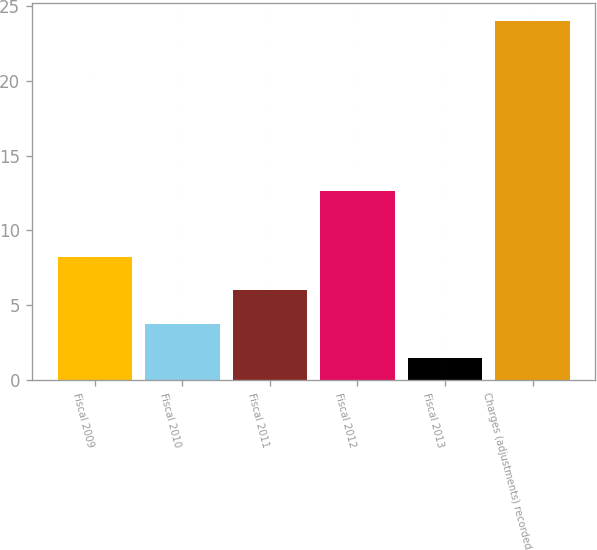Convert chart to OTSL. <chart><loc_0><loc_0><loc_500><loc_500><bar_chart><fcel>Fiscal 2009<fcel>Fiscal 2010<fcel>Fiscal 2011<fcel>Fiscal 2012<fcel>Fiscal 2013<fcel>Charges (adjustments) recorded<nl><fcel>8.25<fcel>3.75<fcel>6<fcel>12.6<fcel>1.5<fcel>24<nl></chart> 